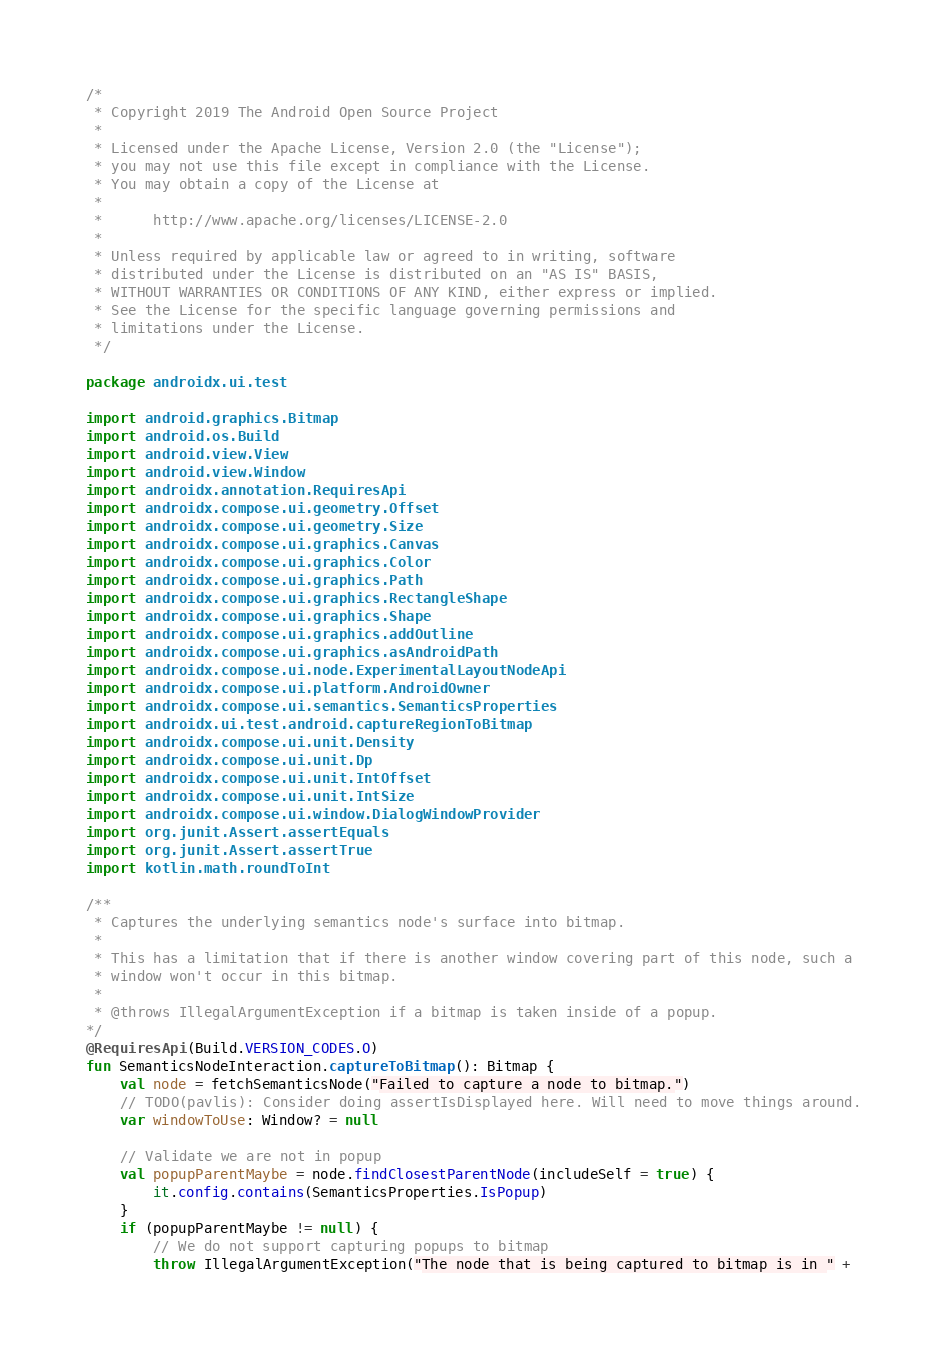Convert code to text. <code><loc_0><loc_0><loc_500><loc_500><_Kotlin_>/*
 * Copyright 2019 The Android Open Source Project
 *
 * Licensed under the Apache License, Version 2.0 (the "License");
 * you may not use this file except in compliance with the License.
 * You may obtain a copy of the License at
 *
 *      http://www.apache.org/licenses/LICENSE-2.0
 *
 * Unless required by applicable law or agreed to in writing, software
 * distributed under the License is distributed on an "AS IS" BASIS,
 * WITHOUT WARRANTIES OR CONDITIONS OF ANY KIND, either express or implied.
 * See the License for the specific language governing permissions and
 * limitations under the License.
 */

package androidx.ui.test

import android.graphics.Bitmap
import android.os.Build
import android.view.View
import android.view.Window
import androidx.annotation.RequiresApi
import androidx.compose.ui.geometry.Offset
import androidx.compose.ui.geometry.Size
import androidx.compose.ui.graphics.Canvas
import androidx.compose.ui.graphics.Color
import androidx.compose.ui.graphics.Path
import androidx.compose.ui.graphics.RectangleShape
import androidx.compose.ui.graphics.Shape
import androidx.compose.ui.graphics.addOutline
import androidx.compose.ui.graphics.asAndroidPath
import androidx.compose.ui.node.ExperimentalLayoutNodeApi
import androidx.compose.ui.platform.AndroidOwner
import androidx.compose.ui.semantics.SemanticsProperties
import androidx.ui.test.android.captureRegionToBitmap
import androidx.compose.ui.unit.Density
import androidx.compose.ui.unit.Dp
import androidx.compose.ui.unit.IntOffset
import androidx.compose.ui.unit.IntSize
import androidx.compose.ui.window.DialogWindowProvider
import org.junit.Assert.assertEquals
import org.junit.Assert.assertTrue
import kotlin.math.roundToInt

/**
 * Captures the underlying semantics node's surface into bitmap.
 *
 * This has a limitation that if there is another window covering part of this node, such a
 * window won't occur in this bitmap.
 *
 * @throws IllegalArgumentException if a bitmap is taken inside of a popup.
*/
@RequiresApi(Build.VERSION_CODES.O)
fun SemanticsNodeInteraction.captureToBitmap(): Bitmap {
    val node = fetchSemanticsNode("Failed to capture a node to bitmap.")
    // TODO(pavlis): Consider doing assertIsDisplayed here. Will need to move things around.
    var windowToUse: Window? = null

    // Validate we are not in popup
    val popupParentMaybe = node.findClosestParentNode(includeSelf = true) {
        it.config.contains(SemanticsProperties.IsPopup)
    }
    if (popupParentMaybe != null) {
        // We do not support capturing popups to bitmap
        throw IllegalArgumentException("The node that is being captured to bitmap is in " +</code> 